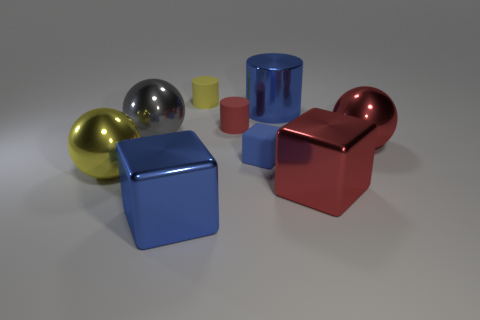There is a block to the left of the tiny rubber object behind the small red rubber cylinder; what is its material?
Make the answer very short. Metal. How big is the shiny cube to the left of the small cylinder behind the blue metal object that is behind the yellow metallic sphere?
Your answer should be very brief. Large. Do the blue metal cylinder and the gray metal object have the same size?
Provide a succinct answer. Yes. There is a yellow matte object behind the red sphere; does it have the same shape as the blue thing that is in front of the tiny blue block?
Offer a terse response. No. There is a tiny thing that is on the left side of the tiny red matte cylinder; are there any small yellow things right of it?
Ensure brevity in your answer.  No. Are any green shiny objects visible?
Your answer should be compact. No. How many red blocks have the same size as the metallic cylinder?
Provide a short and direct response. 1. How many tiny cylinders are both behind the blue cylinder and in front of the small yellow thing?
Offer a terse response. 0. There is a rubber cylinder to the right of the yellow rubber cylinder; is it the same size as the yellow sphere?
Provide a succinct answer. No. Are there any large metallic blocks that have the same color as the metallic cylinder?
Your response must be concise. Yes. 